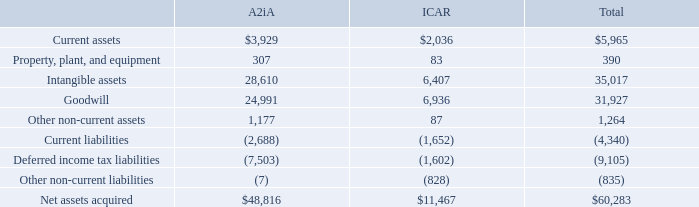ICAR Vision Systems, S.L.
On October 16, 2017, Mitek Holding B.V., a company incorporated under the laws of The Netherlands and a wholly owned subsidiary of the Company (“Mitek Holding B.V.”), acquired all of the issued and outstanding shares of ICAR, a company incorporated under the laws of Spain (the “ICAR Acquisition”), and each of its subsidiaries, pursuant to a Share Purchase Agreement (the “Purchase Agreement”), by and among, the Company, Mitek Holding B.V., and each of the shareholders of ICAR (the “Sellers”). ICAR is a technology provider of identity fraud proofing and document management solutions for web, desktop, and mobile platforms. Upon completion of the ICAR Acquisition, ICAR became a direct wholly owned subsidiary of Mitek Holding B.V. and an indirect wholly owned subsidiary of the Company. ICAR is a leading provider of consumer identity verification solutions in Spain and Latin America. The ICAR Acquisition strengthens the Company’s position as a global digital identity verification powerhouse in the Consumer Identity and Access Management solutions market.
As consideration for the ICAR Acquisition, the Company agreed to an aggregate purchase price of up to $13.9 million, net of cash acquired. On October 16, 2017, the Company: (i) made a cash payment to Sellers of $3.0 million, net of cash acquired and subject to adjustments for transaction expenses, escrow amounts, indebtedness, and working capital adjustments; and (ii) issued to Sellers 584,291 shares, or $5.6 million, of Common Stock. In addition to the foregoing, the Sellers may be entitled to additional cash consideration upon achievement of certain milestones as follows: (a) subject to achievement of the revenue target for the fourth quarter of calendar 2017, the Company will pay to Sellers up to $1.5 million (the “Q4 Consideration”), which amount shall be deposited (as additional funds) into the escrow fund described below; and (b) subject to achievement of certain revenue and net income targets for ICAR for the twelve-month period ending on September 30, 2018, and the twelve-month period ending on September 30, 2019, the Company will pay to Sellers up to $3.8 million in additional cash consideration (the “Earnout Consideration”); provided that if the revenue target set forth in clause (a) is not met, then the Q4 Consideration will instead be added to the Earnout Consideration payable upon (and subject to) achievement of the revenue and net income targets for the twelve-month period ending on September 30, 2018. The Company estimated the fair value of the total Q4 Consideration and Earnout Consideration to be $2.9 million on October 16, 2017, which was determined using a discounted cash flow methodology based on financial forecasts determined by management that included assumptions about revenue growth and discount rates. Each quarter the Company revises the estimated fair value of the Earnout Consideration and revises as necessary.
The Company incurred $0.5 million of expense in connection with the ICAR Acquisition primarily related to legal fees, outside service costs, and travel expense, which are included in acquisition-related costs and expenses in the consolidated statements of operations and other comprehensive income (loss).
On October 16, 2017, the Company deposited $1.5 million of cash into an escrow fund to serve as collateral and partial security for working capital adjustments and certain indemnification rights. In April 2018, the Q4 Consideration of $1.5 million was deposited into the escrow fund. As a result of the achievement of earnout targets during fiscal 2018, the Company paid $1.8 million in January 2019. The Company intends to extend the period over which the remaining $1.8 million of earnout consideration is earned. A portion of the earnout consideration will be paid during first quarter of fiscal 2020 based on the achievement of revenue and income targets earned during fiscal 2019. The remaining portion of the earnout consideration will be paid out during the first quarter of fiscal 2021, which will be based on the achievement of certain revenue, income, development and corporate targets achieved during fiscal 2020. During the first quarter of fiscal 2020, the Company released all escrow funds, excluding $1.0 million which is being held for any potential settlement relating to the claims which may arise from the litigation which was brought on by Global Equity & Corporate Consulting, S.L. against ICAR as more fully described in Note 9.
The Company used cash on hand for cash paid on October 16, 2017, and under the terms of the Purchase Agreement, the Company has agreed to guarantee the obligations of Mitek Holding B.V. thereunder.
Acquisitions are accounted for using the purchase method of accounting in accordance with ASC Topic 805,Business Combinations. Accordingly, the results of operations of A2iA and ICAR have been included in the accompanying consolidated financial statements since the date of each acquisition. The purchase price for both the A2iA Acquisition and the ICAR Acquisition have been allocated to the tangible and intangible assets acquired and liabilities assumed based upon the respective estimates of fair value as of the date of each acquisition, and are based on assumptions that the Company’s management believes are reasonable given the information currently available.
The following table summarizes the estimated fair values of the assets acquired and liabilities assumed during the year ended September 30, 2018 a(mounts shown in thousands):
The goodwill recognized is due to expected synergies and other factors and is not expected to be deductible for income tax purposes. The Company estimated the fair value of identifiable acquisition-related intangible assets with definite lives primarily based on discounted cash flow projections that will arise from these assets. The Company exercised significant judgment with regard to assumptions used in the determination of fair value such as with respect to discount rates and the determination of the estimated useful lives of the intangible assets.
How much money did the Company deposit into an escrow fund in 2017 and 2018, respectively?  $1.5 million, $1.5 million. What is the total net assets acquired from A2iA?
Answer scale should be: thousand. $48,816. What are the estimated fair values of intangible assets of A2iA and ICAR Acquisition, respectively?
Answer scale should be: thousand. 28,610, 6,407. Which acquisition has the highest net assets? 48,816 > 11,467
Answer: a2ia. What is the average of net assets from both A2iA and ICAR acquisitions?
Answer scale should be: thousand. (48,816+11,467)/2 
Answer: 30141.5. What are the total liabilities from both A2iA and ICAR acquisitions?
Answer scale should be: thousand. 2,688+7,503+7+1,652+1,602+828 
Answer: 14280. 